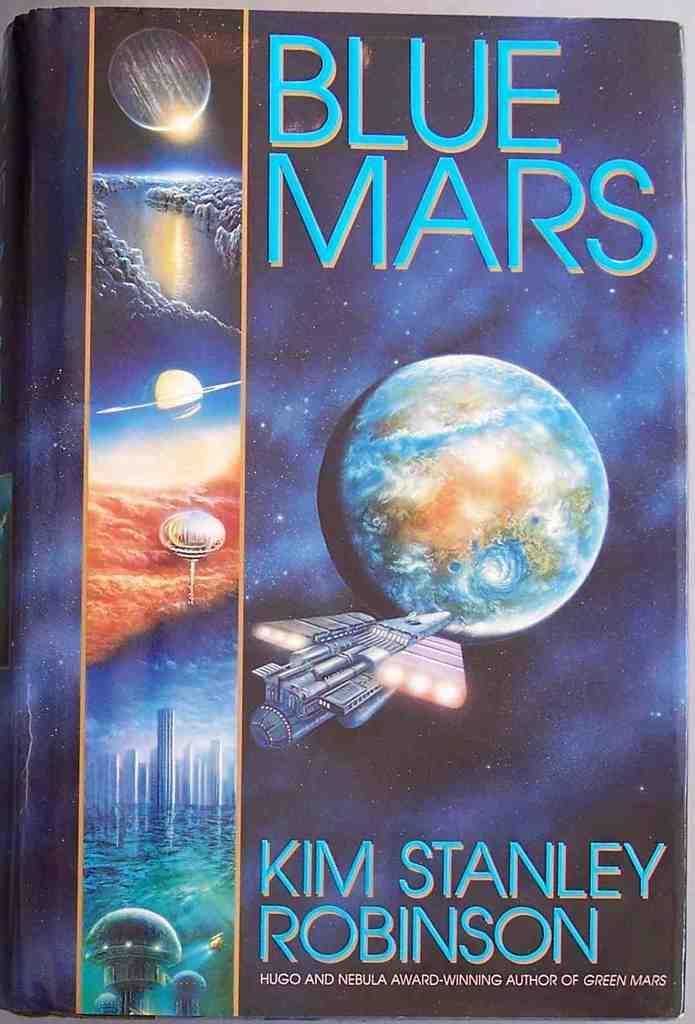Provide a one-sentence caption for the provided image. A book about space is called Blue Mars. 